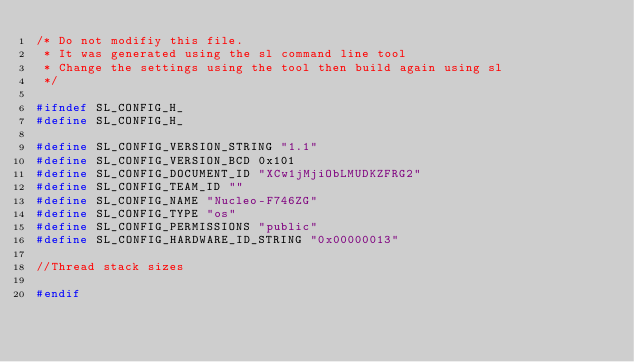<code> <loc_0><loc_0><loc_500><loc_500><_C_>/* Do not modifiy this file.
 * It was generated using the sl command line tool
 * Change the settings using the tool then build again using sl
 */

#ifndef SL_CONFIG_H_
#define SL_CONFIG_H_

#define SL_CONFIG_VERSION_STRING "1.1"
#define SL_CONFIG_VERSION_BCD 0x101
#define SL_CONFIG_DOCUMENT_ID "XCw1jMjiObLMUDKZFRG2"
#define SL_CONFIG_TEAM_ID ""
#define SL_CONFIG_NAME "Nucleo-F746ZG"
#define SL_CONFIG_TYPE "os"
#define SL_CONFIG_PERMISSIONS "public"
#define SL_CONFIG_HARDWARE_ID_STRING "0x00000013"

//Thread stack sizes

#endif

</code> 